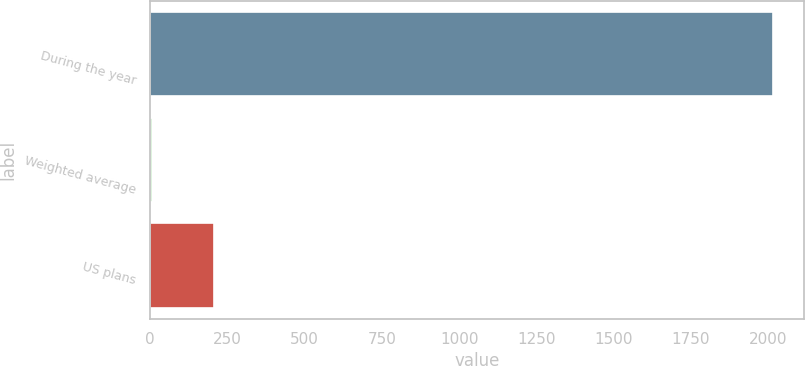<chart> <loc_0><loc_0><loc_500><loc_500><bar_chart><fcel>During the year<fcel>Weighted average<fcel>US plans<nl><fcel>2015<fcel>4.74<fcel>205.77<nl></chart> 